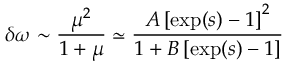Convert formula to latex. <formula><loc_0><loc_0><loc_500><loc_500>\delta \omega \sim \frac { \mu ^ { 2 } } { 1 + \mu } \simeq \frac { A \left [ \exp ( s ) - 1 \right ] ^ { 2 } } { 1 + B \left [ \exp ( { s } ) - 1 \right ] }</formula> 